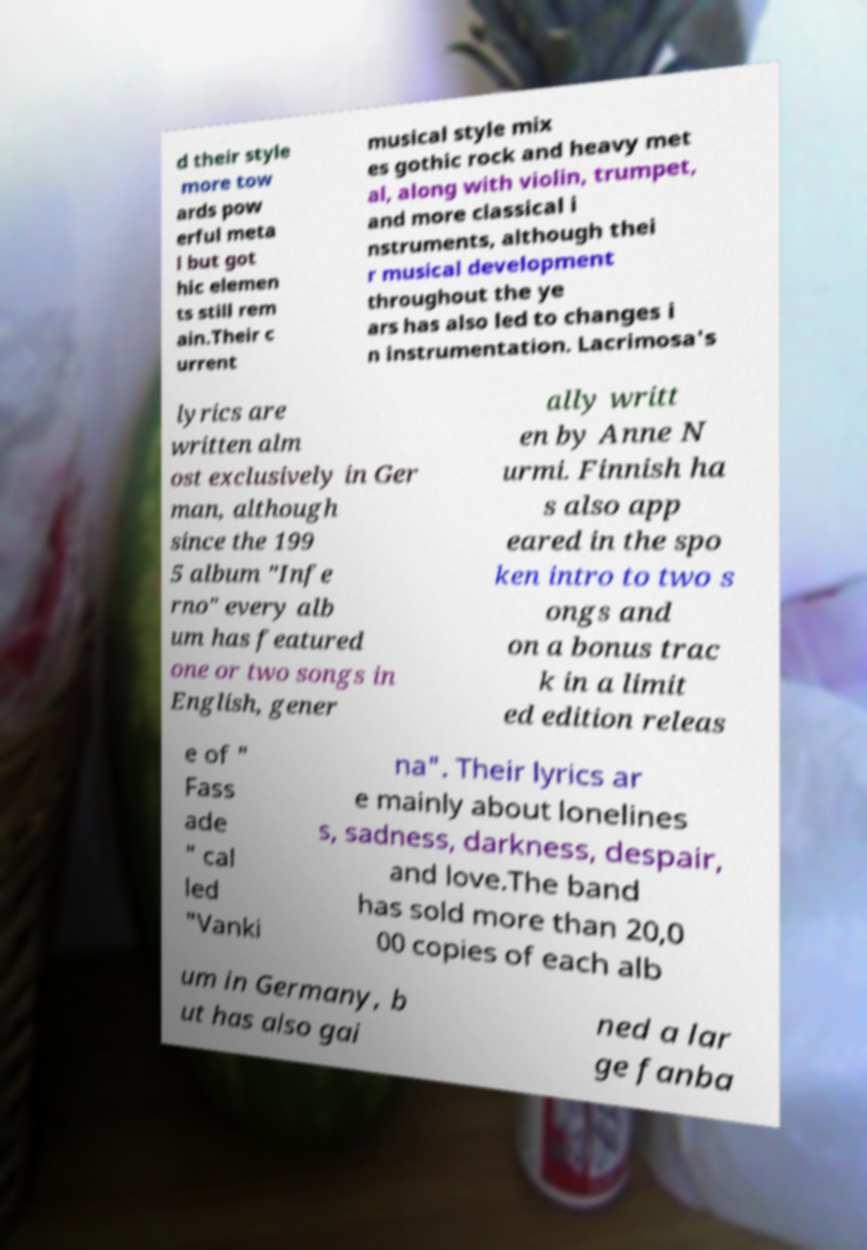What messages or text are displayed in this image? I need them in a readable, typed format. d their style more tow ards pow erful meta l but got hic elemen ts still rem ain.Their c urrent musical style mix es gothic rock and heavy met al, along with violin, trumpet, and more classical i nstruments, although thei r musical development throughout the ye ars has also led to changes i n instrumentation. Lacrimosa's lyrics are written alm ost exclusively in Ger man, although since the 199 5 album "Infe rno" every alb um has featured one or two songs in English, gener ally writt en by Anne N urmi. Finnish ha s also app eared in the spo ken intro to two s ongs and on a bonus trac k in a limit ed edition releas e of " Fass ade " cal led "Vanki na". Their lyrics ar e mainly about lonelines s, sadness, darkness, despair, and love.The band has sold more than 20,0 00 copies of each alb um in Germany, b ut has also gai ned a lar ge fanba 